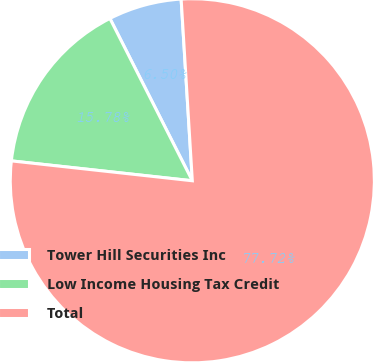Convert chart. <chart><loc_0><loc_0><loc_500><loc_500><pie_chart><fcel>Tower Hill Securities Inc<fcel>Low Income Housing Tax Credit<fcel>Total<nl><fcel>6.5%<fcel>15.78%<fcel>77.72%<nl></chart> 